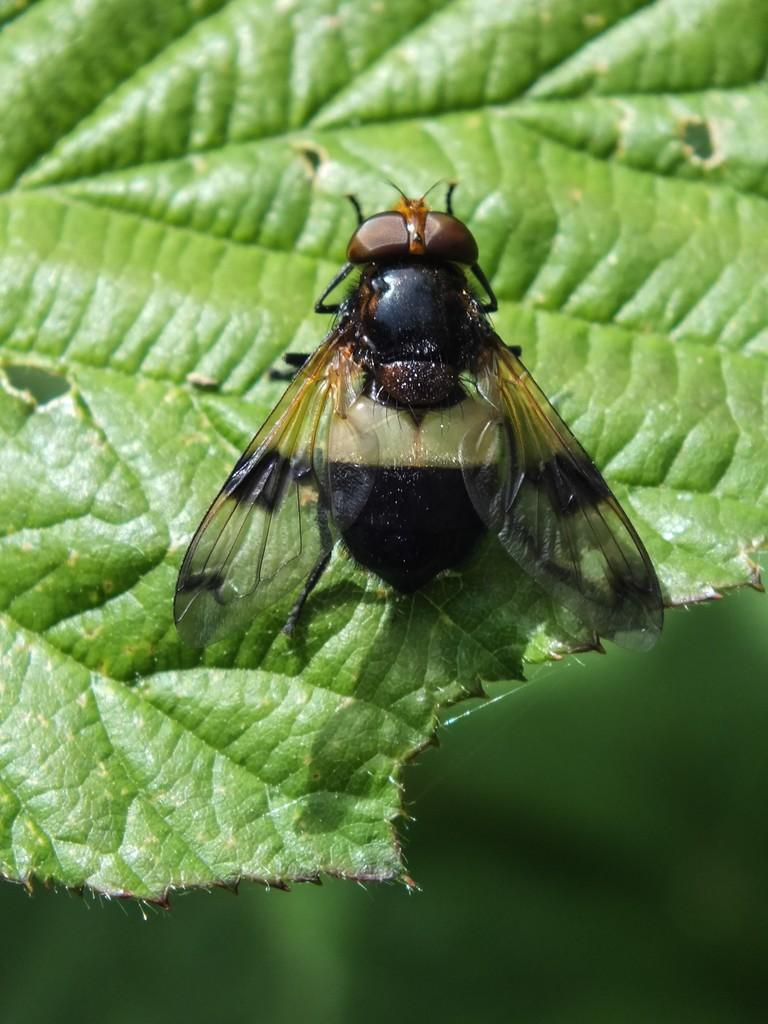What is the main subject of the image? There is a leaf in the image. Is there anything on the leaf? Yes, there is an insect on the leaf. Can you describe the background of the image? The background of the image is blurred. What type of scarf is draped over the leaf in the image? There is no scarf present in the image; it features a leaf with an insect on it. Can you tell me how many bananas are visible in the image? There are no bananas present in the image. 